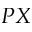Convert formula to latex. <formula><loc_0><loc_0><loc_500><loc_500>P X</formula> 